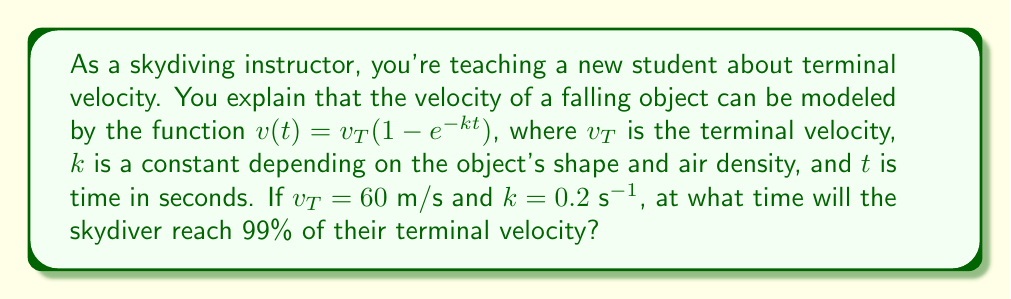Give your solution to this math problem. Let's approach this step-by-step:

1) We want to find $t$ when $v(t) = 0.99v_T$

2) Substituting this into our equation:
   $$0.99v_T = v_T(1 - e^{-kt})$$

3) Dividing both sides by $v_T$:
   $$0.99 = 1 - e^{-kt}$$

4) Subtracting both sides from 1:
   $$0.01 = e^{-kt}$$

5) Taking the natural log of both sides:
   $$\ln(0.01) = -kt$$

6) Solving for $t$:
   $$t = -\frac{\ln(0.01)}{k}$$

7) We know $k = 0.2$ s$^{-1}$, so let's substitute:
   $$t = -\frac{\ln(0.01)}{0.2}$$

8) Calculating:
   $$t \approx 23.03\text{ s}$$

Therefore, the skydiver will reach 99% of their terminal velocity after approximately 23.03 seconds.
Answer: $23.03\text{ s}$ 